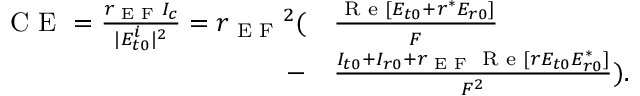<formula> <loc_0><loc_0><loc_500><loc_500>\begin{array} { r l } { C E = \frac { r _ { E F } I _ { c } } { | E _ { t 0 } ^ { i } | ^ { 2 } } = { r _ { E F } } ^ { 2 } ( } & \frac { R e [ E _ { t 0 } + r ^ { * } E _ { r 0 } ] } { F } } \\ { - } & \frac { I _ { t 0 } + I _ { r 0 } + r _ { E F } R e [ r E _ { t 0 } E _ { r 0 } ^ { * } ] } { F ^ { 2 } } ) . } \end{array}</formula> 